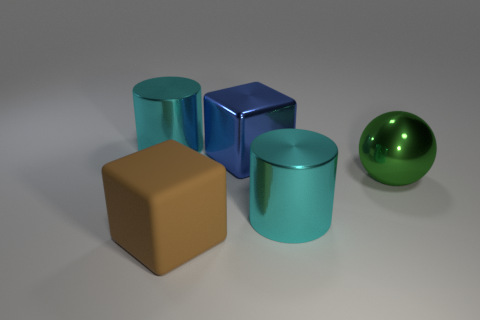There is a large cyan cylinder on the left side of the big cylinder that is on the right side of the big brown matte cube; what is its material?
Ensure brevity in your answer.  Metal. Are there any big gray metallic objects that have the same shape as the blue metal thing?
Offer a terse response. No. What number of other objects are the same shape as the large blue shiny object?
Offer a terse response. 1. There is a thing that is both left of the large green shiny thing and on the right side of the metallic cube; what shape is it?
Provide a short and direct response. Cylinder. How big is the cyan thing that is on the left side of the brown rubber thing?
Ensure brevity in your answer.  Large. Is the blue cube the same size as the green metallic ball?
Provide a succinct answer. Yes. Is the number of large blue shiny cubes that are on the right side of the blue thing less than the number of things that are to the left of the brown object?
Ensure brevity in your answer.  Yes. There is a metallic thing that is both behind the big sphere and to the right of the big rubber thing; what size is it?
Your answer should be compact. Large. There is a large cyan metallic cylinder to the right of the large cyan cylinder on the left side of the brown matte thing; are there any large green balls on the right side of it?
Give a very brief answer. Yes. Are there any big cyan shiny objects?
Offer a very short reply. Yes. 